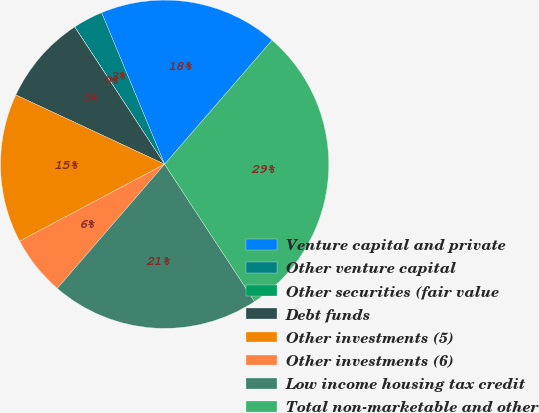<chart> <loc_0><loc_0><loc_500><loc_500><pie_chart><fcel>Venture capital and private<fcel>Other venture capital<fcel>Other securities (fair value<fcel>Debt funds<fcel>Other investments (5)<fcel>Other investments (6)<fcel>Low income housing tax credit<fcel>Total non-marketable and other<nl><fcel>17.64%<fcel>2.95%<fcel>0.01%<fcel>8.83%<fcel>14.7%<fcel>5.89%<fcel>20.58%<fcel>29.4%<nl></chart> 